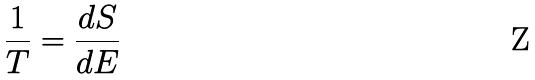<formula> <loc_0><loc_0><loc_500><loc_500>\frac { 1 } { T } = \frac { d S } { d E }</formula> 